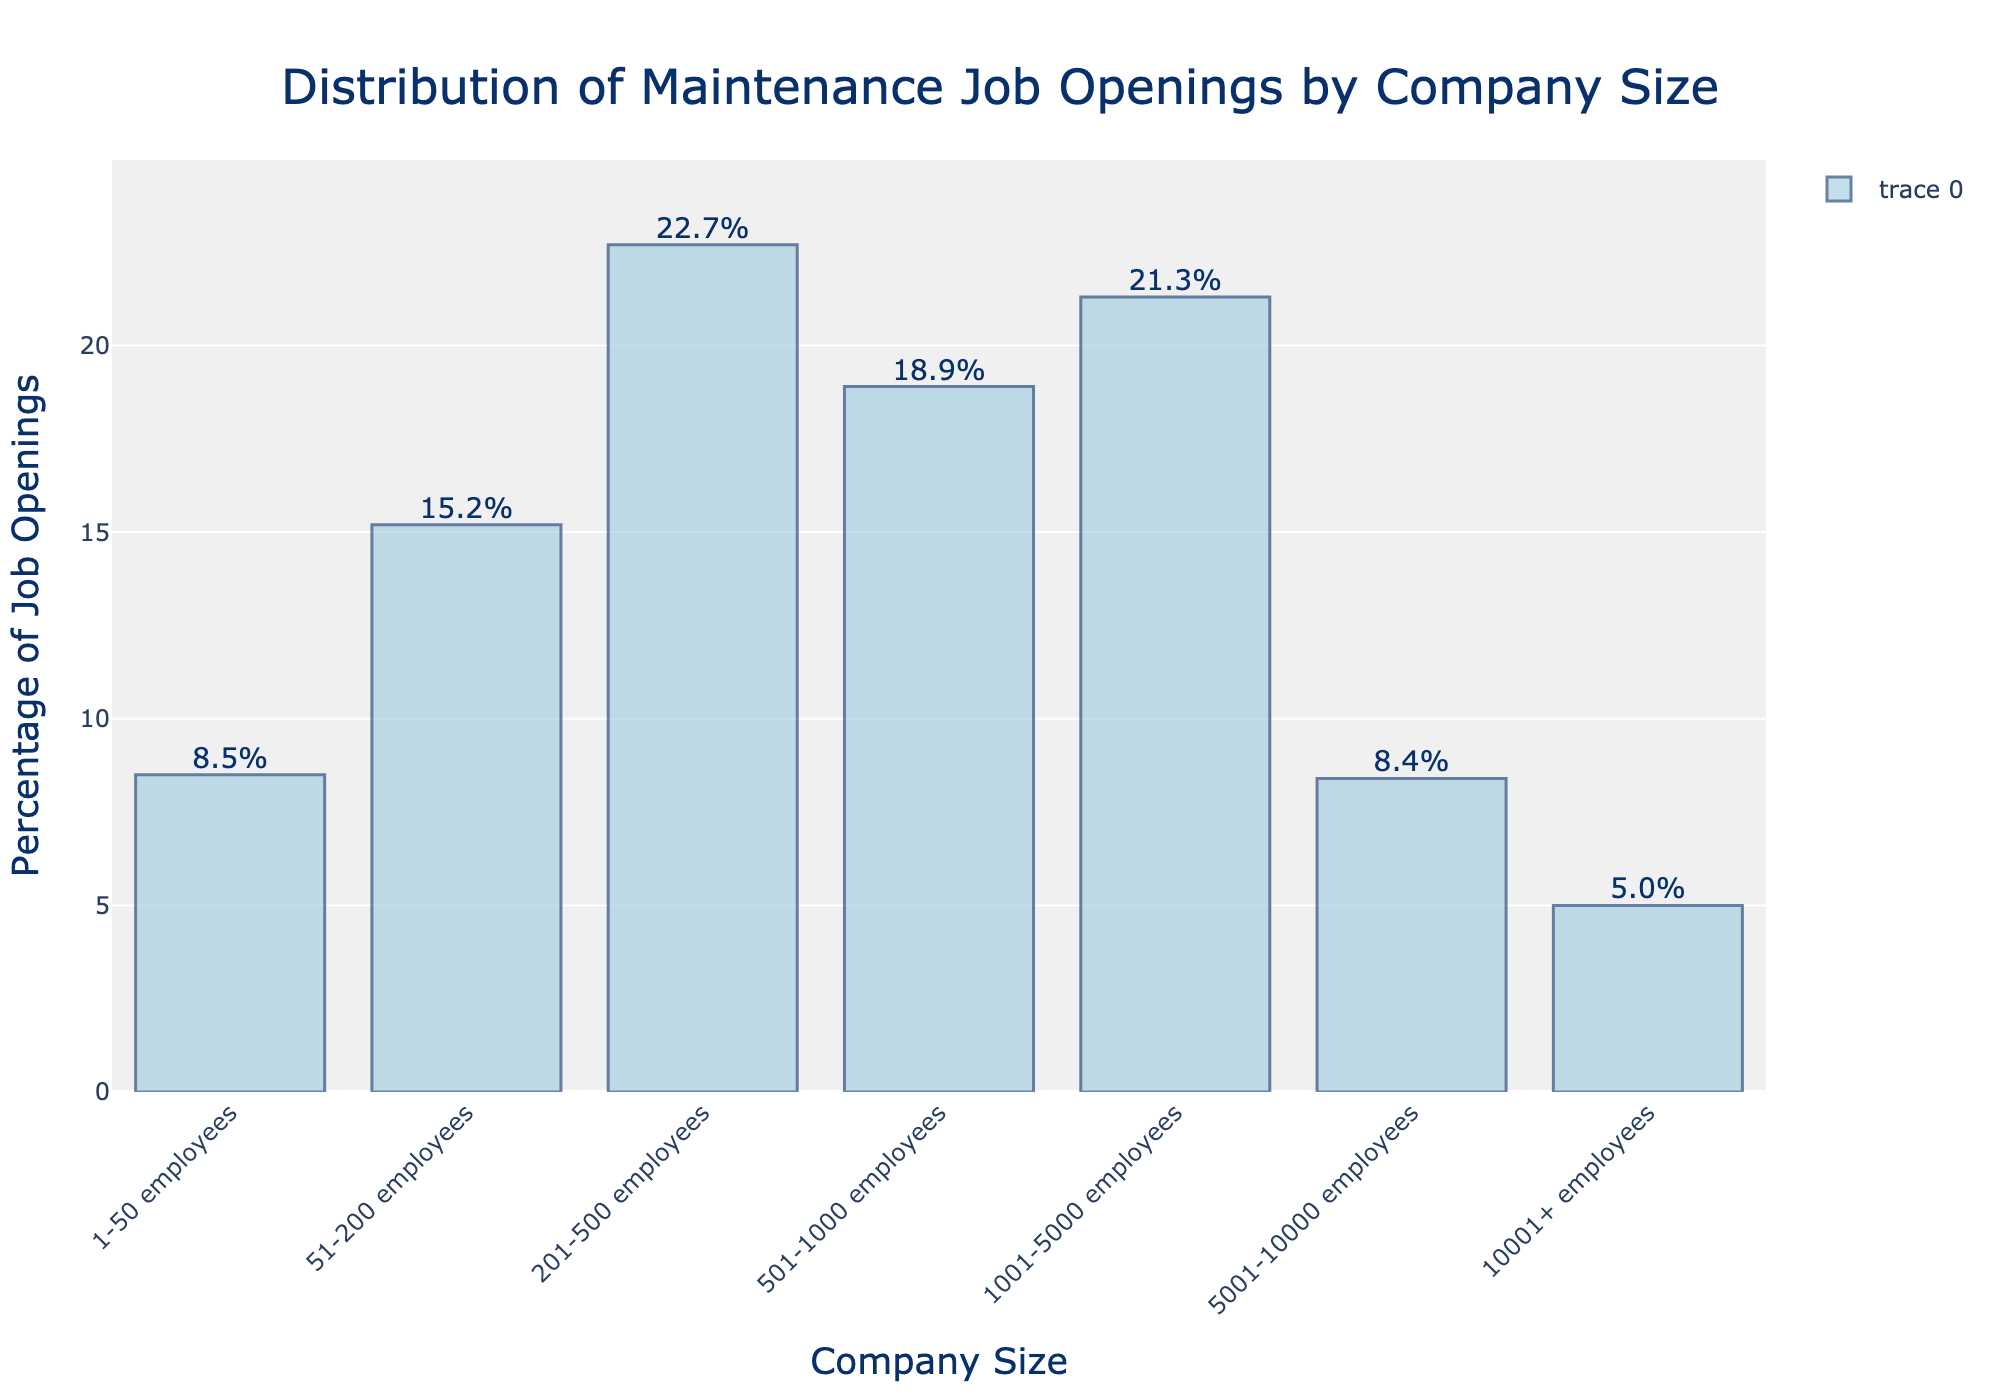Which company size has the highest percentage of maintenance job openings? The bar representing company sizes 201-500 employees is the tallest, indicating the highest percentage of job openings.
Answer: 201-500 employees How does the percentage of job openings for companies with 1-50 employees compare to those with 51-200 employees? The bar for 1-50 employees reaches 8.5%, while the bar for 51-200 employees is higher at 15.2%.
Answer: The percentage for 1-50 employees is less than for 51-200 employees What is the combined percentage of job openings for companies with 201-500 and 1001-5000 employees? Add both percentages: 22.7% (201-500 employees) + 21.3% (1001-5000 employees) = 44.0%.
Answer: 44.0% What is the difference in the percentage of job openings between companies with 501-1000 employees and those with 5001-10000 employees? Subtract the percentage of 5001-10000 employees (8.4%) from 501-1000 employees (18.9%): 18.9% - 8.4% = 10.5%.
Answer: 10.5% What company size has the lowest percentage of maintenance job openings? The shortest bar corresponds to company sizes with 10001+ employees, showing 5.0% job openings.
Answer: 10001+ employees Which two adjacent company sizes have the smallest difference in the percentage of job openings? Calculate the differences between each pair of adjacent bars: The smallest difference is between 1-50 employees (8.5%) and 5001-10000 employees (8.4%) with a difference of 0.1%.
Answer: 1-50 and 5001-10000 employees How much greater is the percentage of job openings for companies with 201-500 employees compared to those with 10001+ employees? Subtract the percentage of 10001+ employees (5.0%) from 201-500 employees (22.7%): 22.7% - 5.0% = 17.7%.
Answer: 17.7% What is the average percentage of job openings for companies with 200 or fewer employees? Add the percentages of 1-50 employees (8.5%) and 51-200 employees (15.2%), then divide by 2: (8.5% + 15.2%) / 2 = 11.85%.
Answer: 11.85% Which company sizes have more than 20% of the job openings? The bars for 201-500 employees (22.7%) and 1001-5000 employees (21.3%) are above 20%.
Answer: 201-500 and 1001-5000 employees 